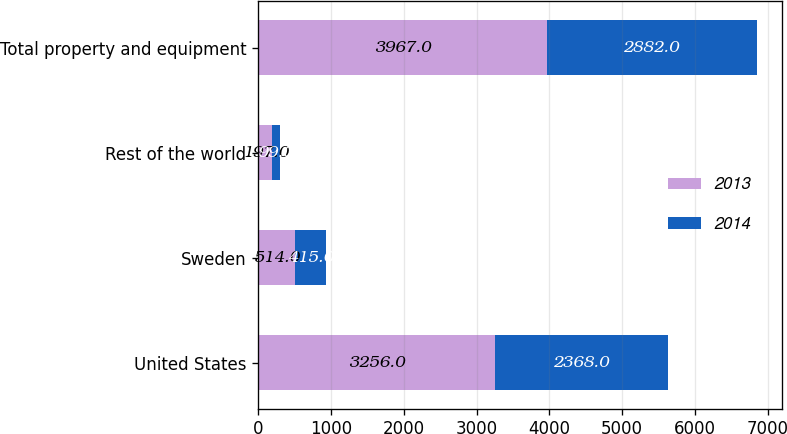<chart> <loc_0><loc_0><loc_500><loc_500><stacked_bar_chart><ecel><fcel>United States<fcel>Sweden<fcel>Rest of the world<fcel>Total property and equipment<nl><fcel>2013<fcel>3256<fcel>514<fcel>197<fcel>3967<nl><fcel>2014<fcel>2368<fcel>415<fcel>99<fcel>2882<nl></chart> 